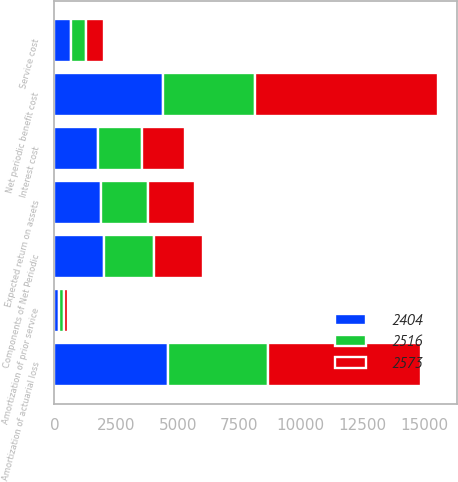Convert chart to OTSL. <chart><loc_0><loc_0><loc_500><loc_500><stacked_bar_chart><ecel><fcel>Components of Net Periodic<fcel>Expected return on assets<fcel>Amortization of prior service<fcel>Amortization of actuarial loss<fcel>Net periodic benefit cost<fcel>Service cost<fcel>Interest cost<nl><fcel>2573<fcel>2012<fcel>1902.5<fcel>157<fcel>6221<fcel>7406<fcel>735<fcel>1758<nl><fcel>2404<fcel>2011<fcel>1902.5<fcel>198<fcel>4624<fcel>4391<fcel>685<fcel>1764<nl><fcel>2516<fcel>2010<fcel>1902.5<fcel>198<fcel>4026<fcel>3753<fcel>609<fcel>1795<nl></chart> 